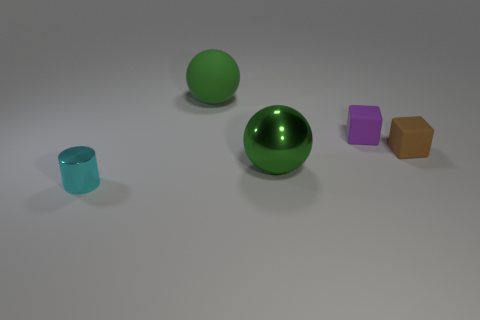What is the brown object that is in front of the rubber thing that is behind the rubber cube that is behind the small brown matte thing made of?
Give a very brief answer. Rubber. How many objects are made of the same material as the small cylinder?
Your answer should be very brief. 1. What is the shape of the thing that is the same color as the large matte sphere?
Keep it short and to the point. Sphere. What is the shape of the cyan thing that is the same size as the purple cube?
Give a very brief answer. Cylinder. What material is the ball that is the same color as the big shiny thing?
Your response must be concise. Rubber. Are there any tiny cyan things in front of the shiny sphere?
Your answer should be compact. Yes. Is there a large green matte thing that has the same shape as the big green metal object?
Make the answer very short. Yes. There is a big object that is behind the big green metal object; is its shape the same as the metal object to the right of the large matte sphere?
Provide a succinct answer. Yes. Are there any cubes of the same size as the cyan object?
Make the answer very short. Yes. Are there an equal number of small purple cubes on the right side of the small brown rubber object and tiny purple blocks that are in front of the small purple rubber object?
Offer a terse response. Yes. 